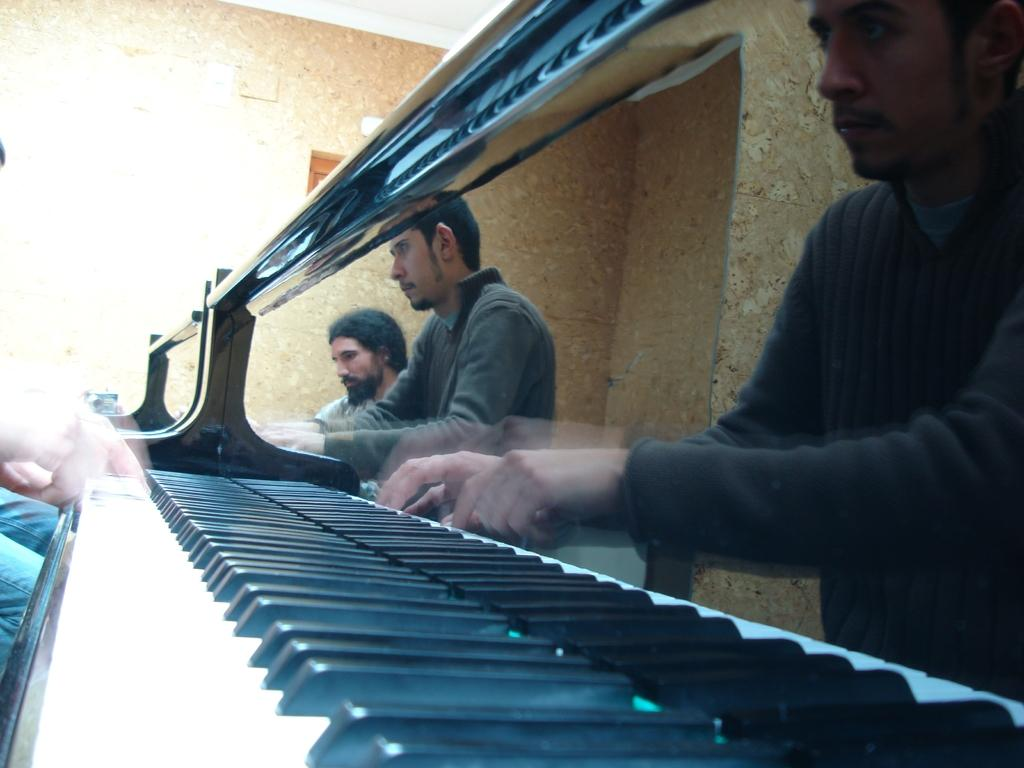What are the people in the image doing? The people in the image are playing musical keyboards. What type of cap is the laborer wearing in the image? There is no laborer or cap present in the image; it features people playing musical keyboards. What date is marked on the calendar in the image? There is no calendar present in the image. 